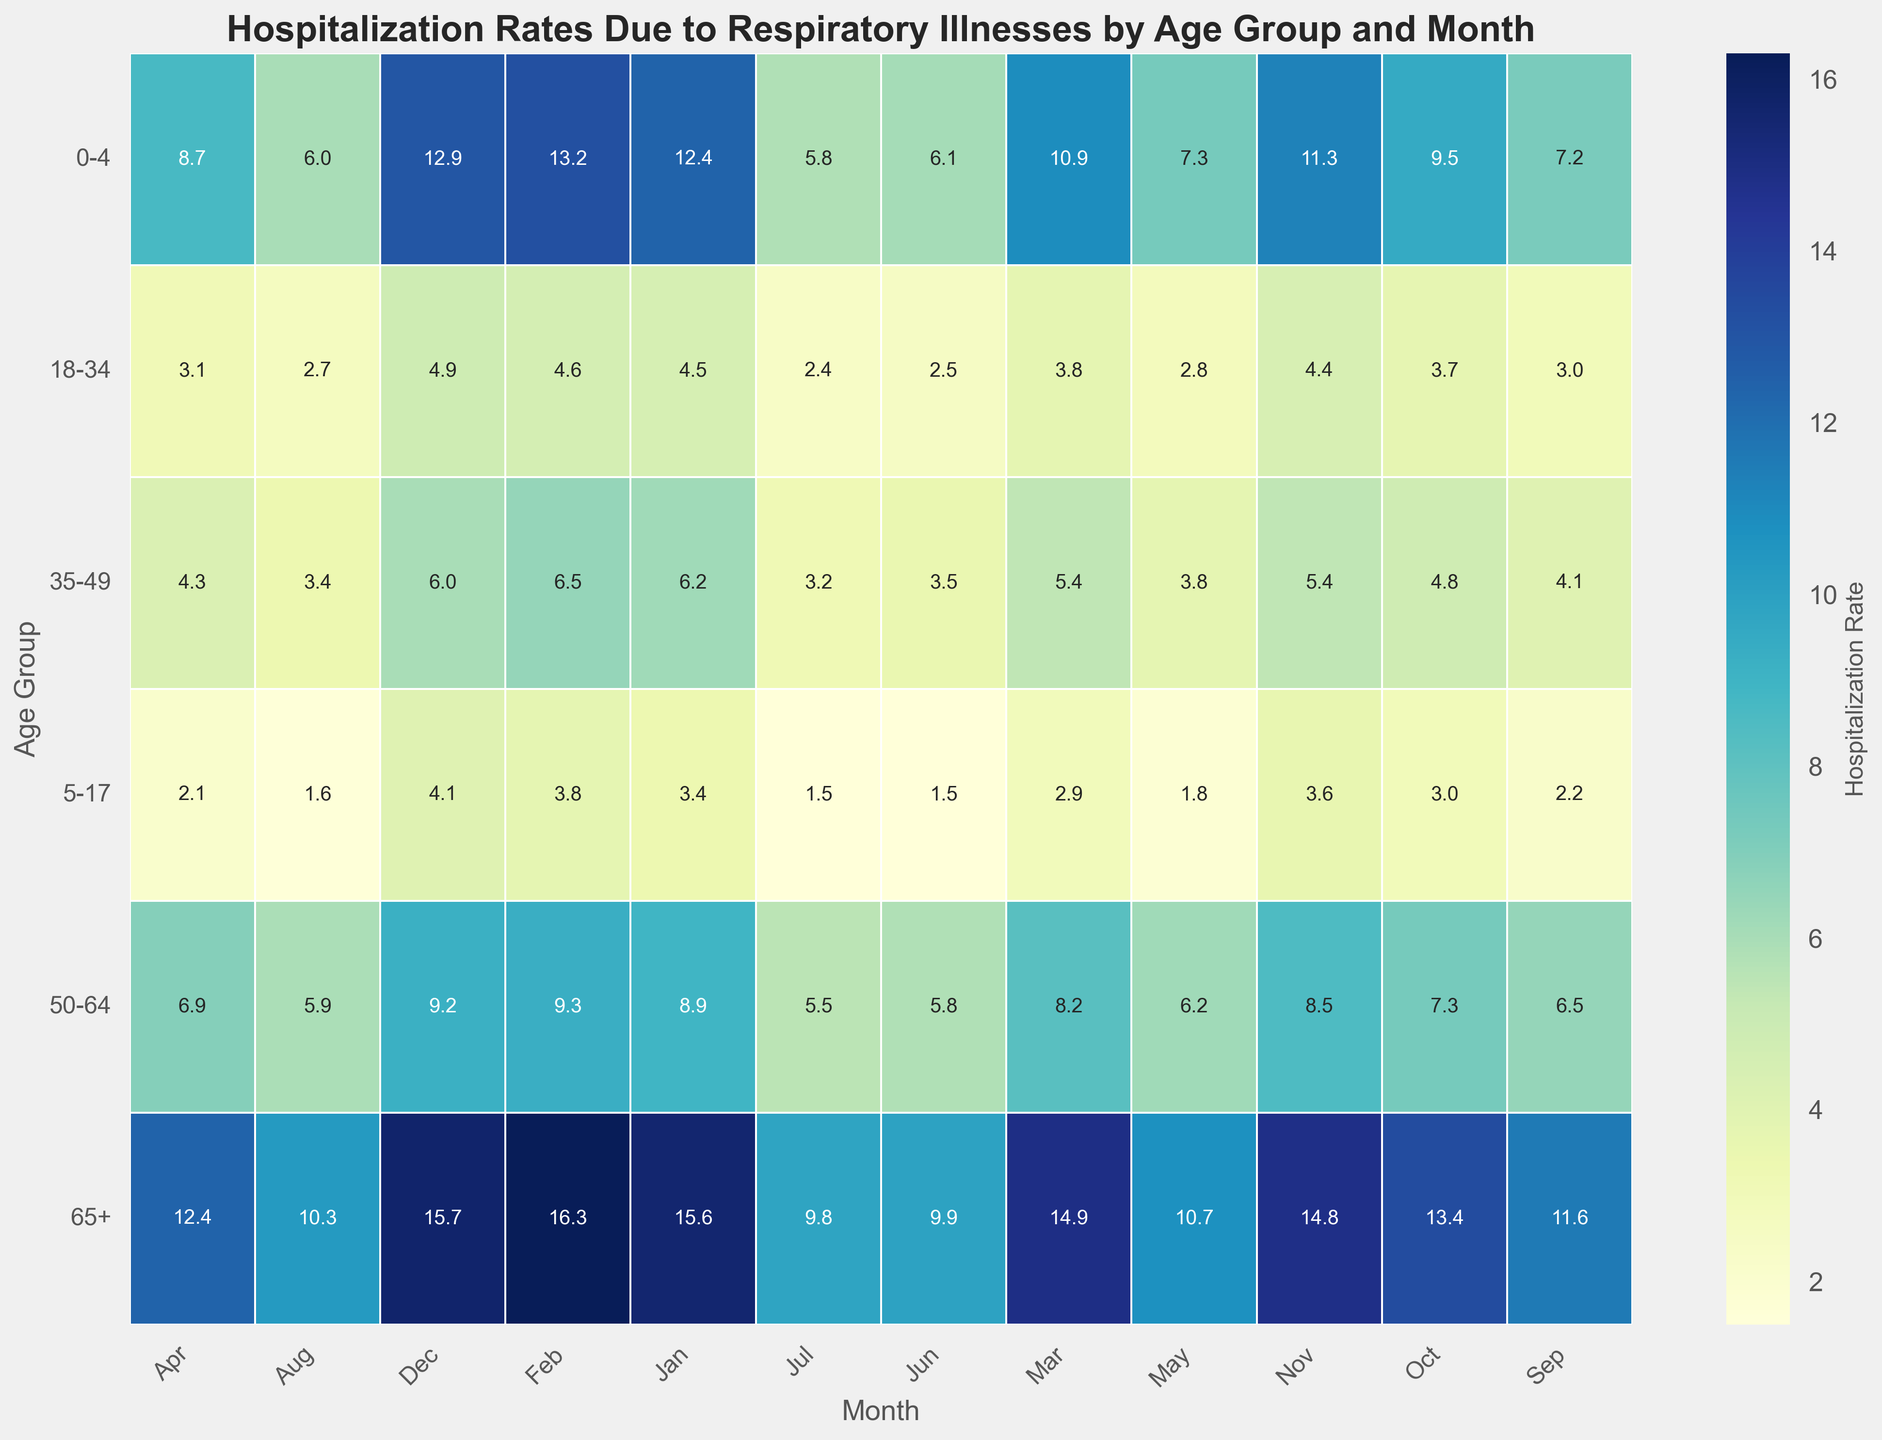What is the average hospitalization rate for the 0-4 age group across all months? Sum the hospitalization rates for each month in the 0-4 age group: 12.4 + 13.2 + 10.9 + 8.7 + 7.3 + 6.1 + 5.8 + 6.0 + 7.2 + 9.5 + 11.3 + 12.9 = 111.3. Then divide by the number of months (12): 111.3 / 12 = 9.275
Answer: 9.3 Which age group had the highest hospitalization rate in August? Check the hospitalization rate for each age group in August: 0-4 (6.0), 5-17 (1.6), 18-34 (2.7), 35-49 (3.4), 50-64 (5.9), 65+ (10.3). The highest value is for the 65+ age group.
Answer: 65+ In which month did the 18-34 age group record the lowest hospitalization rate? Check the hospitalization rates for each month for the 18-34 age group: Jan (4.5), Feb (4.6), Mar (3.8), Apr (3.1), May (2.8), Jun (2.5), Jul (2.4), Aug (2.7), Sep (3.0), Oct (3.7), Nov (4.4), Dec (4.9). The lowest value is in July at 2.4.
Answer: July How much higher is the December hospitalization rate for the 65+ age group compared to the May hospitalization rate for the same group? Subtract the hospitalization rate in May from the rate in December for the 65+ age group: 15.7 - 10.7 = 5.0
Answer: 5.0 Which two consecutive months show the most significant increase in hospitalization rates for the 5-17 age group? Calculate the differences between consecutive months: Feb-Jan (0.4), Mar-Feb (-0.9), Apr-Mar (-0.8), May-Apr (-0.3), Jun-May (-0.3), Jul-Jun (0), Aug-Jul (0.1), Sep-Aug (0.6), Oct-Sep (0.8), Nov-Oct (0.6), Dec-Nov (0.5). The largest increase is from October to November: 0.6.
Answer: September to October What is the combined hospitalization rate for infants (0-4 age group) in the first and last month of the year? Sum the hospitalization rates in January and December for the 0-4 age group: 12.4 + 12.9 = 25.3
Answer: 25.3 During which quarter (three-month period) does the 50-64 age group have the lowest average hospitalization rates? Calculate the average for each quarter: Q1 (Jan-Mar): (8.9 + 9.3 + 8.2)/3 = 8.13, Q2 (Apr-Jun): (6.9 + 6.2 + 5.8)/3 = 6.3, Q3 (Jul-Sep): (5.5 + 5.9 + 6.5)/3 = 5.97, Q4 (Oct-Dec): (7.3 + 8.5 + 9.2)/3 = 8.33. The lowest average is in Q3.
Answer: Q3 